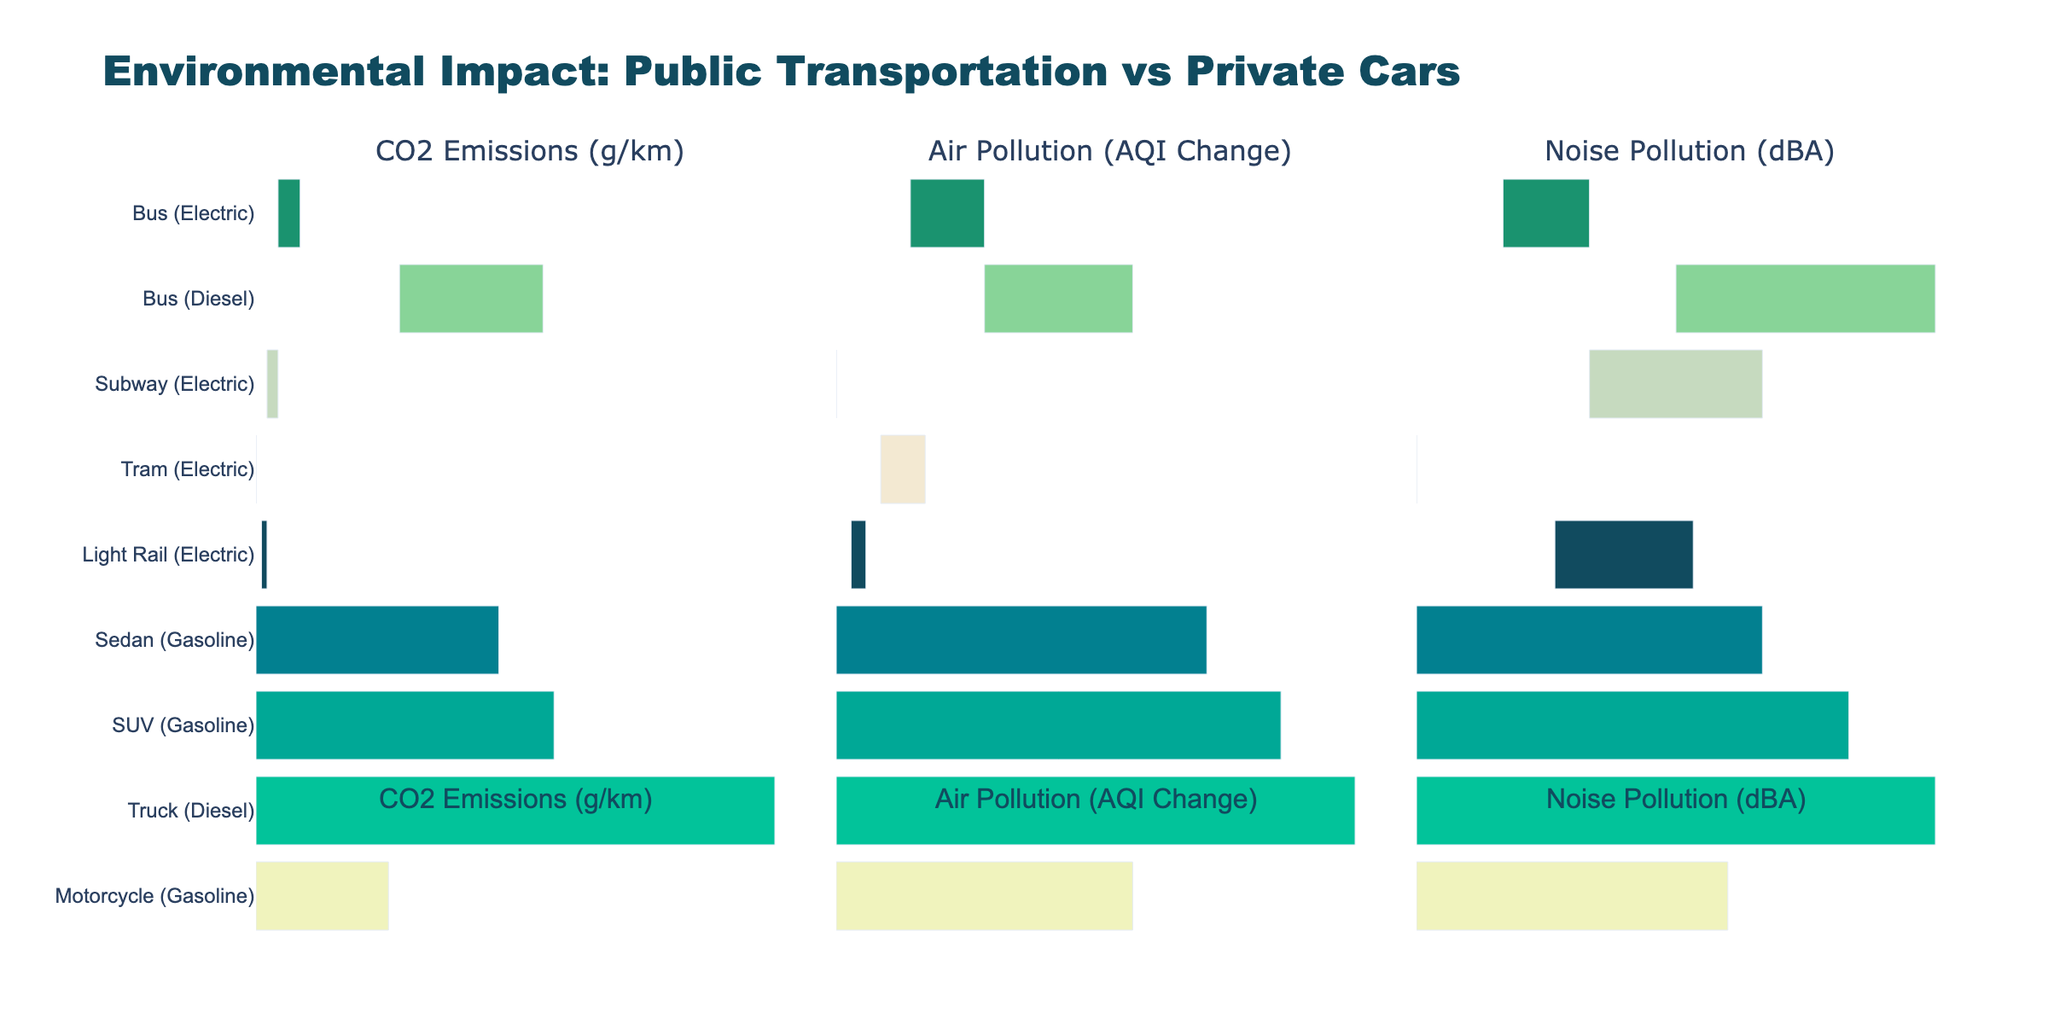What transportation mode has the lowest CO2 emissions? The chart shows the CO2 emissions for each transportation mode. The Tram (Electric) has the lowest CO2 emissions at 30 g/km.
Answer: Tram (Electric) Which transportation mode has the best air quality improvement impact? The chart displays the Air Pollution (AQI Change) for each transportation mode, with lower numbers indicating better air quality. The Subway (Electric) shows the highest improvement with an AQI change of -15.
Answer: Subway (Electric) Compare the noise pollution levels between the Bus (Electric) and the Sedan (Gasoline). Which is quieter? The chart shows the noise pollution (dBA) for each transportation mode. The Bus (Electric) has a noise level of 65 dBA, while the Sedan (Gasoline) has a noise level of 80 dBA. Thus, the Bus (Electric) is quieter.
Answer: Bus (Electric) What is the average CO2 emission of all public transport modes? To find the average CO2 emission for public transport modes: (50 + 160 + 40 + 30 + 35) / 5 = 63 g/km.
Answer: 63 g/km How does the air pollution of the SUV (Gasoline) compare to the Bus (Diesel)? The chart shows the air pollution (AQI Change) for both modes. The SUV (Gasoline) has an AQI change of 15, while the Bus (Diesel) has an AQI change of -5. The SUV pollutes more because it increases AQI, whereas the Bus decreases it.
Answer: SUV (Gasoline) Which transportation mode has the highest noise pollution? The chart indicates the noise pollution levels for each mode. The Truck (Diesel) has the highest noise pollution level at 90 dBA.
Answer: Truck (Diesel) Rank all modes of public transportation from lowest to highest CO2 emissions. Review the CO2 emissions for public transportation modes: Tram (Electric) with 30, Light Rail (Electric) with 35, Subway (Electric) with 40, Bus (Electric) with 50, and Bus (Diesel) with 160. Thus, the ranking is: Tram (Electric), Light Rail (Electric), Subway (Electric), Bus (Electric), Bus (Diesel).
Answer: Tram < Light Rail < Subway < Bus < Bus (Diesel) What is the total air pollution change (AQI) for all private car modes combined? Sum the AQI changes for private car modes: 10 (Sedan) + 15 (SUV) + 20 (Truck) + 5 (Motorcycle) = 50.
Answer: 50 Compare CO2 emissions between private cars and public transport modes. Which group is more environmentally friendly? Review the CO2 emissions data: The highest CO2 emissions in public transport modes is 160 (Bus Diesel), while the lowest in private cars is 150 (Motorcycle). In general, public transportation modes have lower CO2 emissions, making them more environmentally friendly.
Answer: Public transport How much quieter is the Tram (Electric) compared to the Truck (Diesel)? The noise pollution levels for the Tram (Electric) and Truck (Diesel) are 60 dBA and 90 dBA, respectively. The difference is 90 - 60 = 30 dBA, meaning the Tram is 30 dBA quieter.
Answer: 30 dBA 